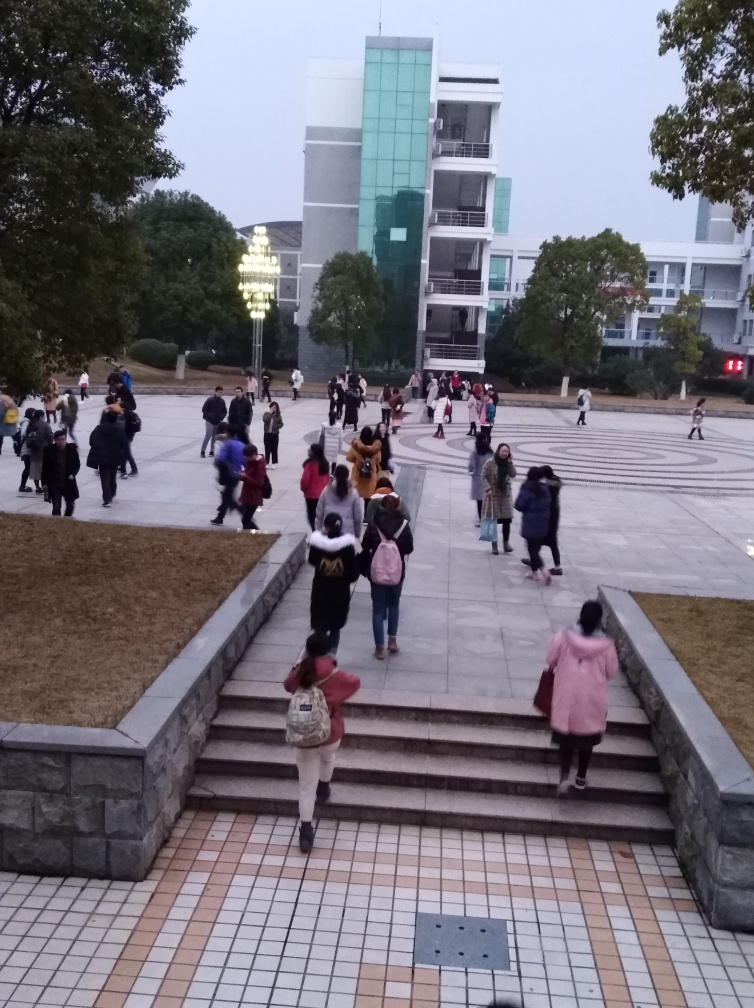What is the overall clarity of the image? The image exhibits some level of blur, particularly visible in the subjects' faces and the finer details of the environment, indicating a moderate level of clarity that affects the ability to discern fine details. The lighting conditions appear to be dull, probably due to overcast weather or the time of day being either early morning or late evening, which also contributes to the overall image quality. 